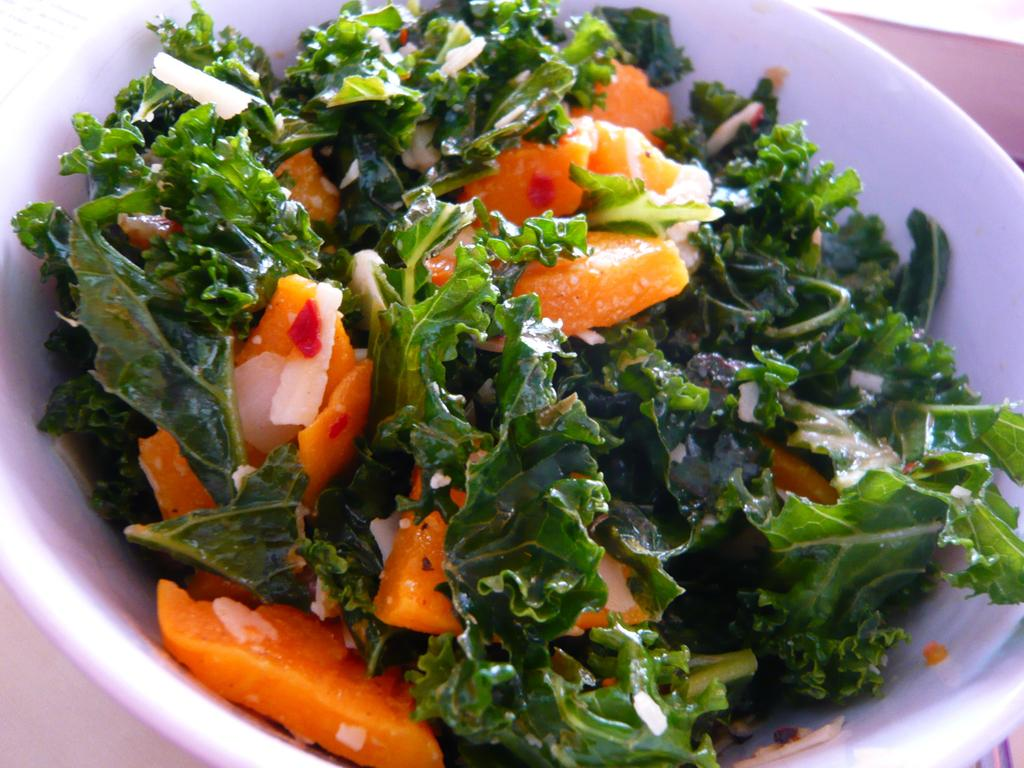What type of food is visible in the image? There are leafy vegetables and chopped fruits in the image. How are the chopped fruits arranged in the image? The chopped fruits are placed in a bowl. What type of street is visible in the image? There is no street present in the image; it features leafy vegetables and chopped fruits. How many guns can be seen in the image? There are no guns present in the image. 